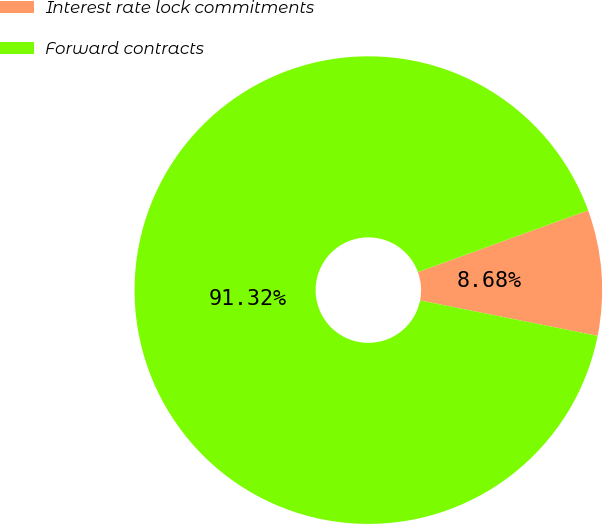<chart> <loc_0><loc_0><loc_500><loc_500><pie_chart><fcel>Interest rate lock commitments<fcel>Forward contracts<nl><fcel>8.68%<fcel>91.32%<nl></chart> 